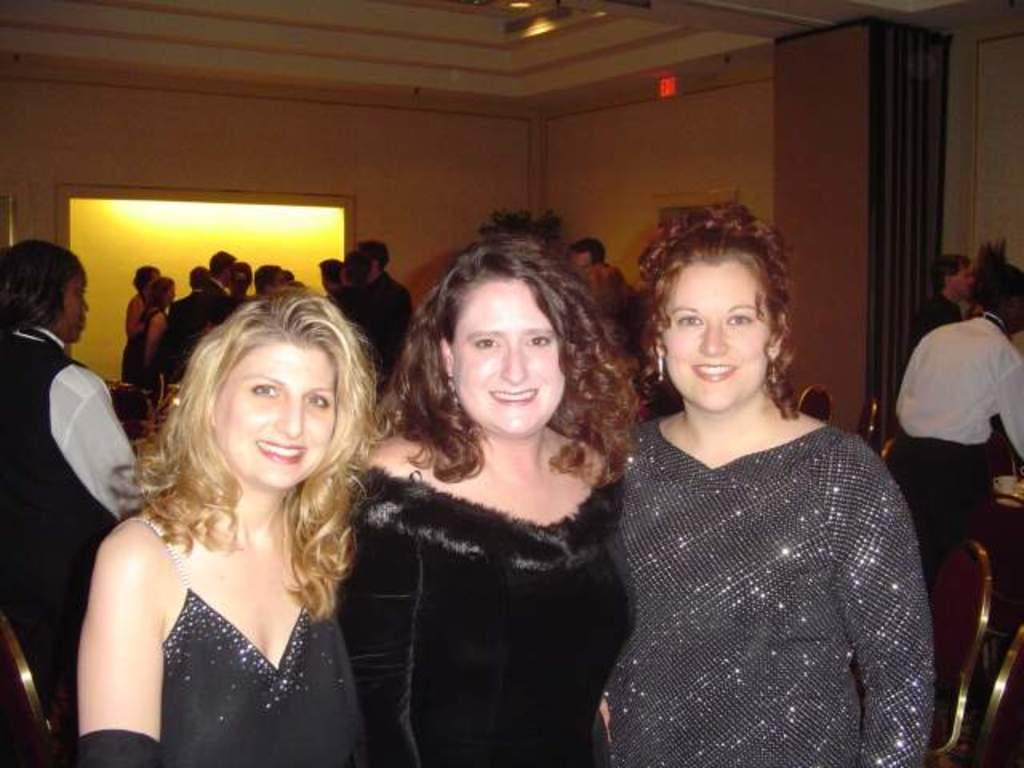How many ladies are in the center of the image? There are three ladies standing in the center of the image. What expression do the ladies have? The ladies are smiling. Can you describe the background of the image? There are people, chairs, a wall, and lights visible in the background. What type of steel structure can be seen in the image? There is no steel structure present in the image. How many crows are perched on the wall in the background? There are no crows visible in the image; only people, chairs, a wall, and lights are present in the background. 